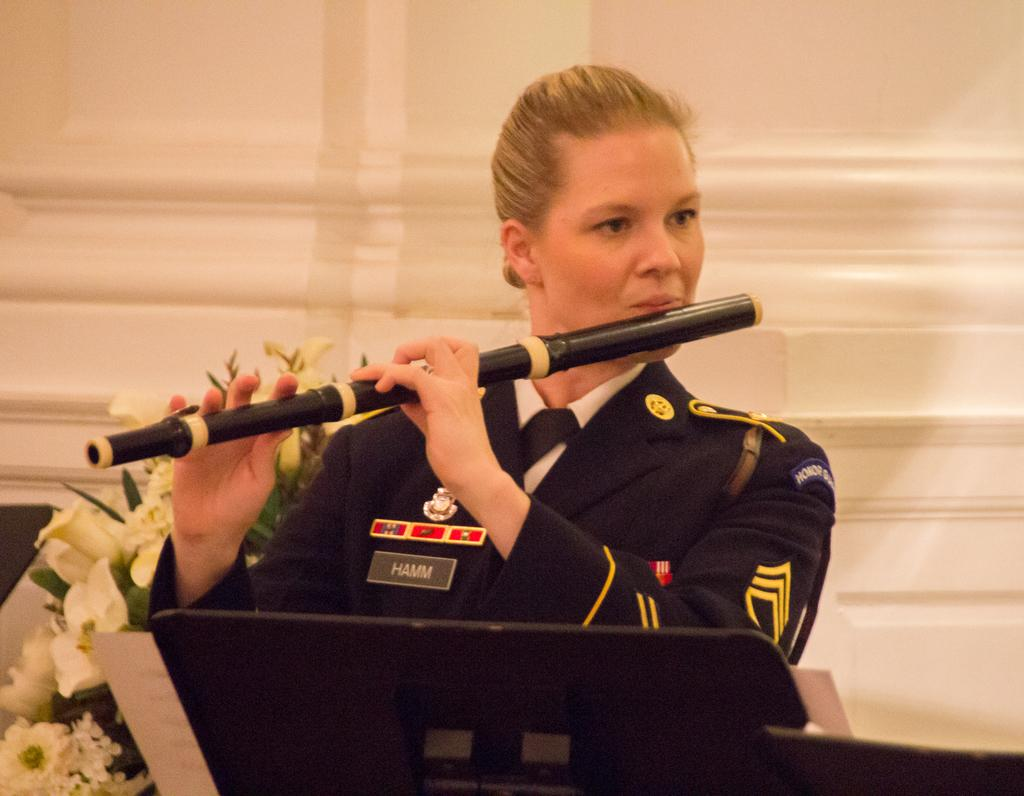Who is the main subject in the image? There is a woman standing in the center of the image. What is the woman holding in the image? The woman is holding a flute. What can be seen besides the woman in the image? There is a bouquet and a black color object in the image. What is visible in the background of the image? There is a curtain in the background of the image. How many eggs are present in the image? There are no eggs visible in the image. What type of debt is the woman trying to pay off in the image? There is no mention of debt in the image; it features a woman holding a flute and other objects. 